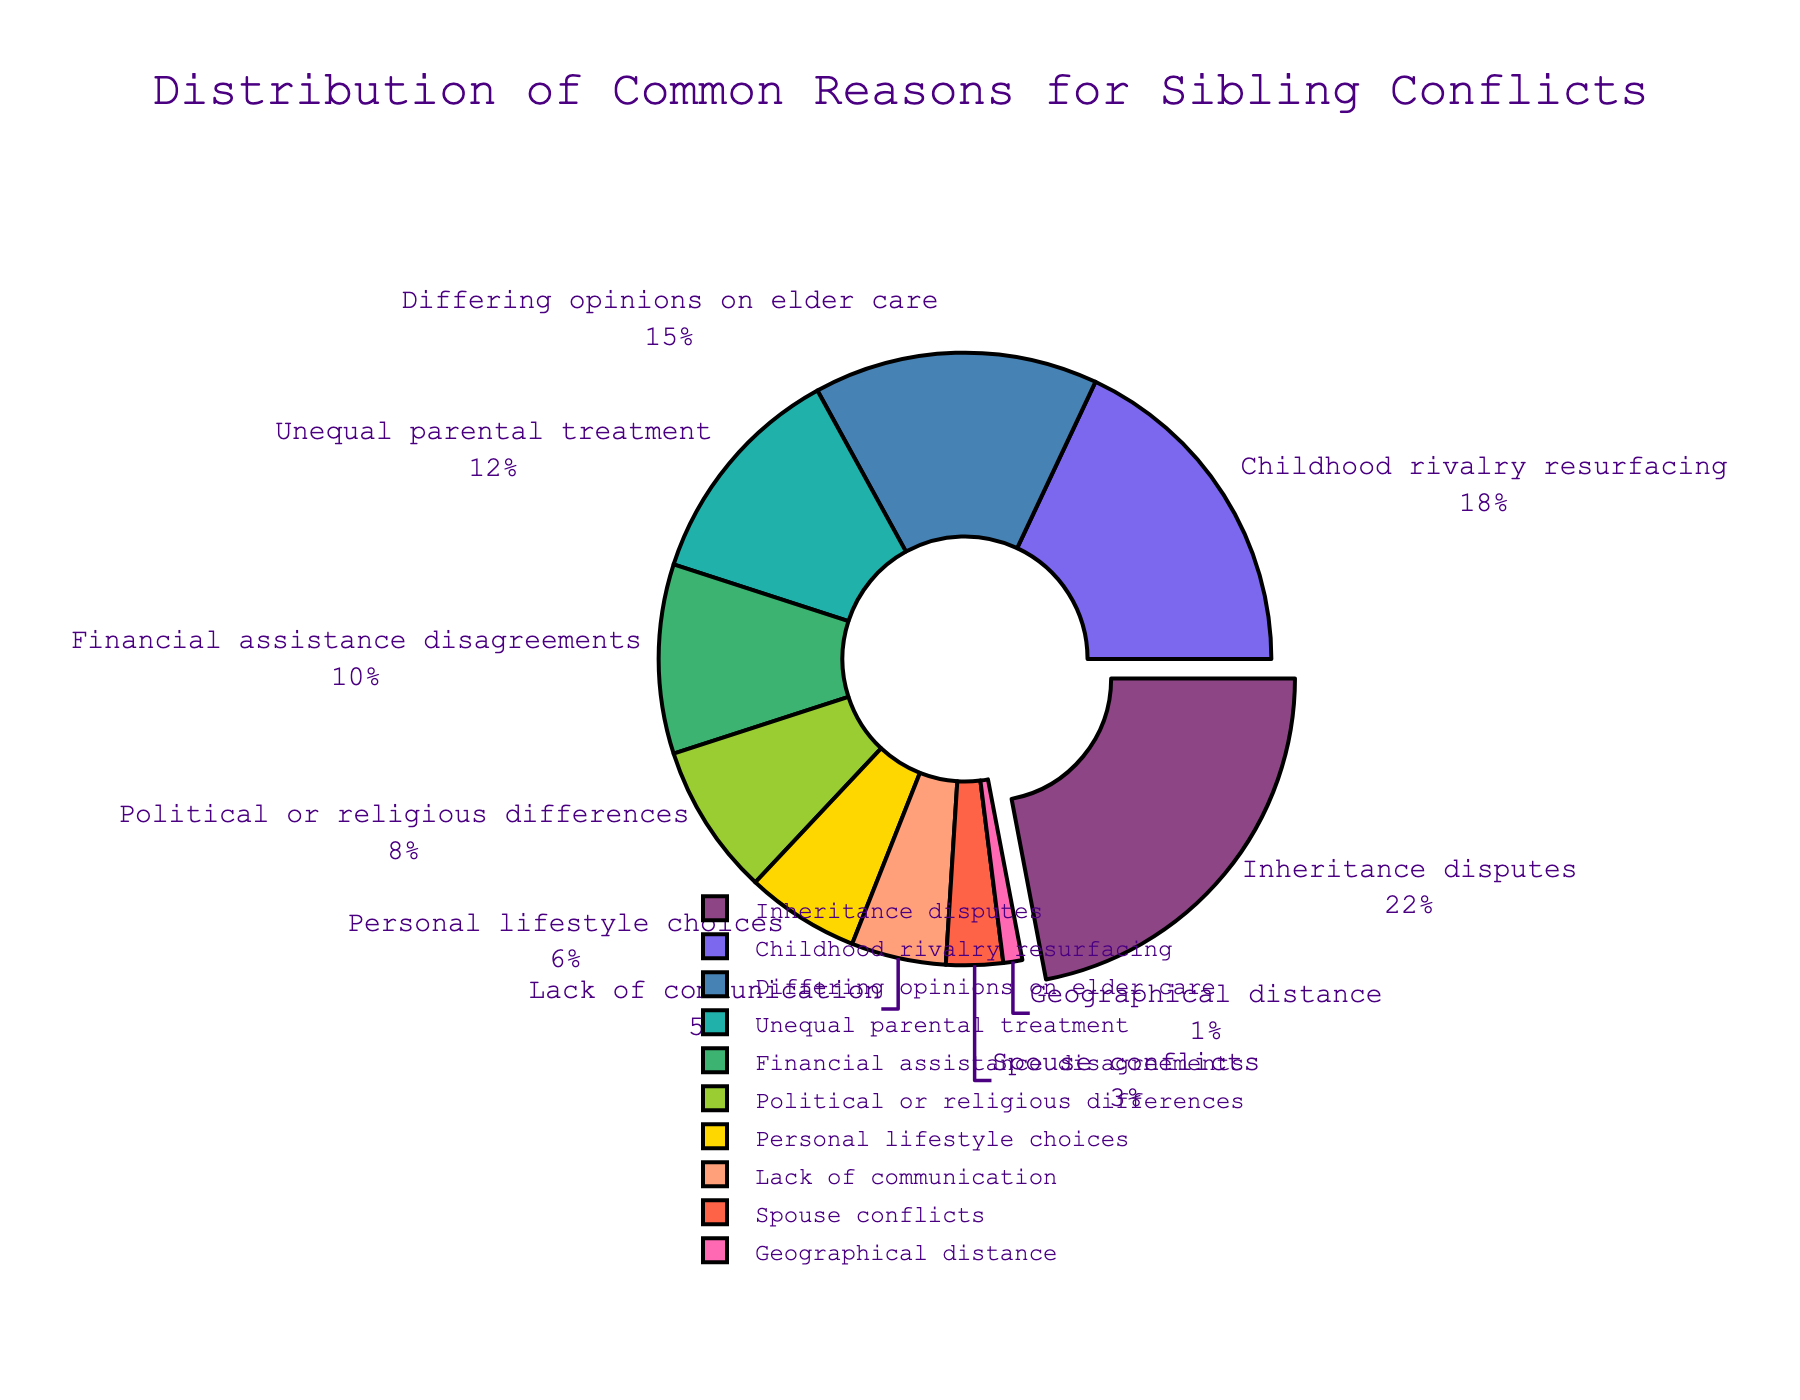Which reason has the highest percentage of sibling conflicts? Inheritance disputes have the largest slice of the pie chart, indicating that this reason has the highest percentage.
Answer: Inheritance disputes What is the combined percentage of conflicts due to 'Financial assistance disagreements' and 'Political or religious differences'? According to the pie chart, 'Financial assistance disagreements' accounts for 10% and 'Political or religious differences' account for 8%. Adding these together gives 10% + 8% = 18%.
Answer: 18% How much greater is the percentage of conflicts related to 'Differing opinions on elder care' compared to 'Lack of communication'? 'Differing opinions on elder care' account for 15% of conflicts, while 'Lack of communication' accounts for 5%. The difference is 15% - 5% = 10%.
Answer: 10% What percentage of conflicts are related to 'Childhood rivalry resurfacing' and how does it compare to 'Unequal parental treatment'? 'Childhood rivalry resurfacing' accounts for 18% while 'Unequal parental treatment' accounts for 12% of the conflicts. So 'Childhood rivalry resurfacing' is 6% greater than 'Unequal parental treatment'.
Answer: 6% If you combine the percentages of 'Personal lifestyle choices' and 'Spouse conflicts', is it higher or lower than 'Differing opinions on elder care'? 'Personal lifestyle choices' account for 6% and 'Spouse conflicts' account for 3%. Combined, they make 6% + 3% = 9%. 'Differing opinions on elder care' account for 15%, which is higher.
Answer: lower Which reasons account for a minority of conflicts, totaling to less than or equal to 10%? From the pie chart, the reasons that account for 10% or less are 'Financial assistance disagreements' (10%), 'Political or religious differences' (8%), 'Personal lifestyle choices' (6%), 'Lack of communication' (5%), 'Spouse conflicts' (3%), and 'Geographical distance' (1%).
Answer: Financial assistance disagreements, Political or religious differences, Personal lifestyle choices, Lack of communication, Spouse conflicts, Geographical distance What is the total percentage for all the reasons combined in the pie chart? The total percentage can be calculated by summing up all the percentages: 22% + 18% + 15% + 12% + 10% + 8% + 6% + 5% + 3% + 1% = 100%.
Answer: 100% Which reason contributes the least to sibling conflicts according to the pie chart, and what is the percentage? The smallest slice of the pie chart corresponds to 'Geographical distance' with a percentage of 1%.
Answer: Geographical distance, 1% What is the percentage difference between 'Inheritance disputes' and 'Political or religious differences'? 'Inheritance disputes' account for 22%, and 'Political or religious differences' account for 8%. The difference is 22% - 8% = 14%.
Answer: 14% 